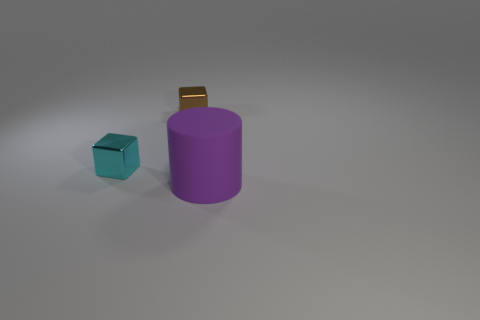Add 3 yellow things. How many objects exist? 6 Subtract all cylinders. How many objects are left? 2 Add 1 big rubber objects. How many big rubber objects exist? 2 Subtract 1 cyan cubes. How many objects are left? 2 Subtract all large purple metallic objects. Subtract all tiny cubes. How many objects are left? 1 Add 3 metal things. How many metal things are left? 5 